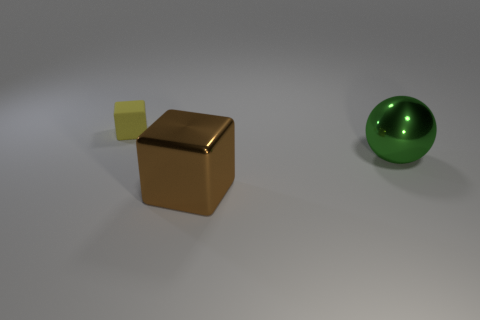Can you describe the lighting and mood of the scene? The scene is illuminated by a soft light source that casts subtle shadows, creating a calm and neutral ambiance. The gentle lighting and the simplicity of the composition give the image a minimalistic feel that is both modern and uncluttered. 